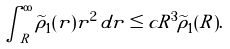Convert formula to latex. <formula><loc_0><loc_0><loc_500><loc_500>\int _ { R } ^ { \infty } \widetilde { \rho } _ { 1 } ( r ) r ^ { 2 } \, d r \leq c R ^ { 3 } \widetilde { \rho } _ { 1 } ( R ) .</formula> 